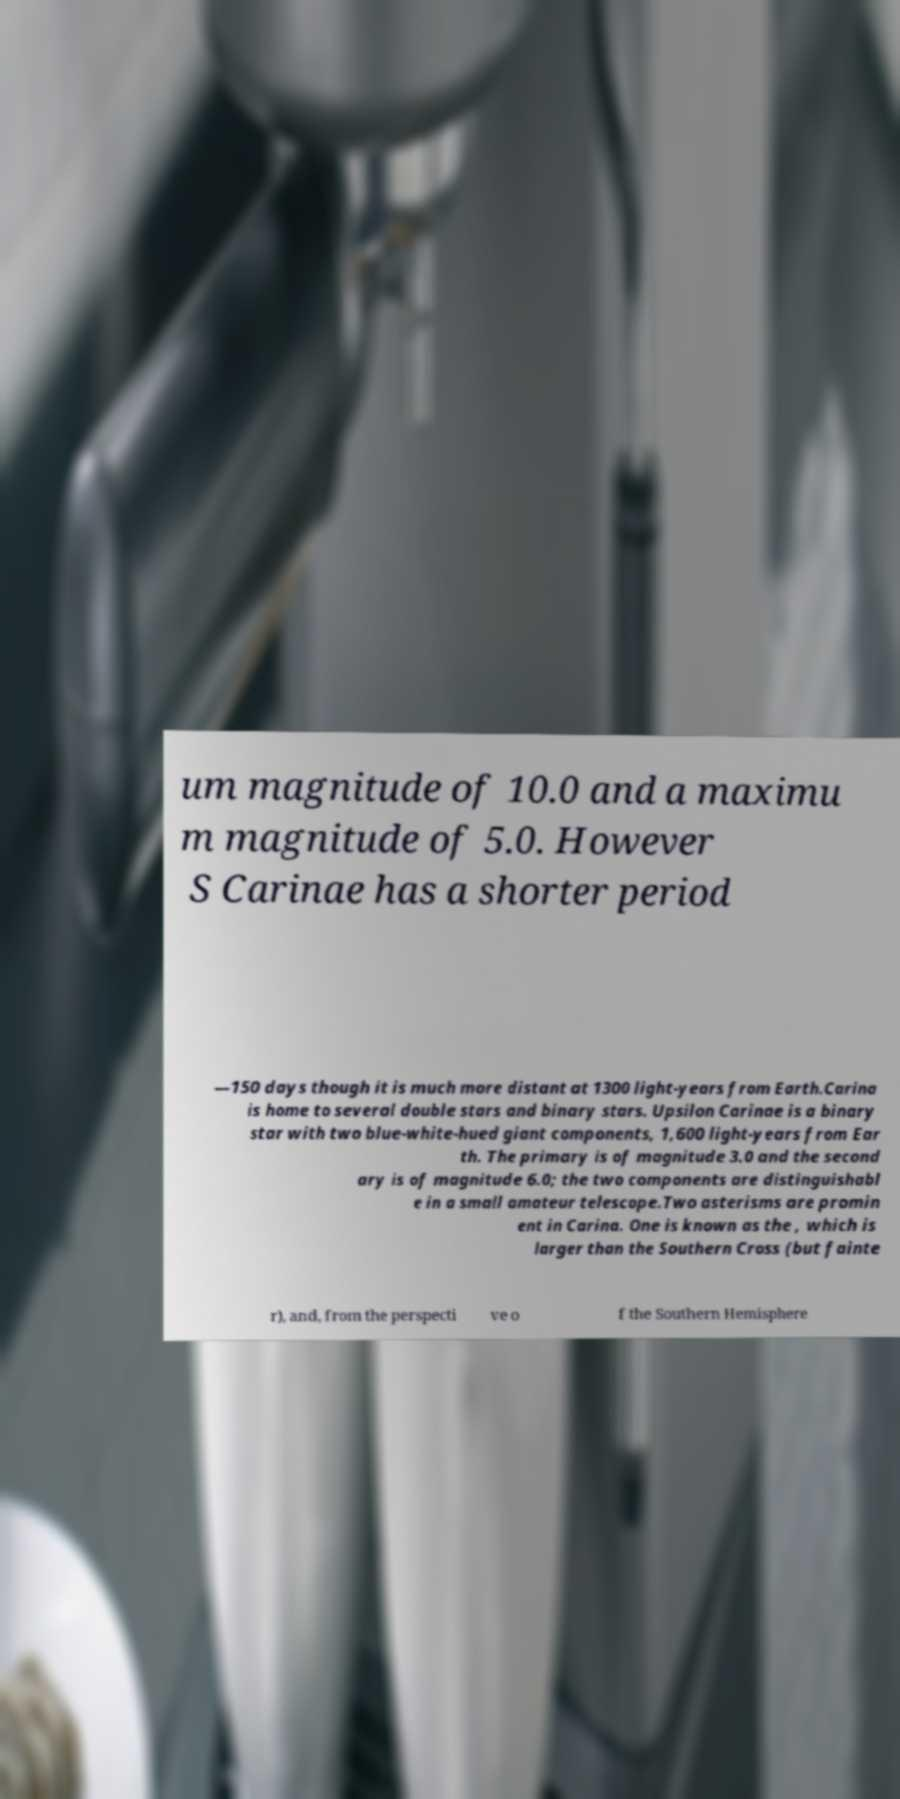Could you assist in decoding the text presented in this image and type it out clearly? um magnitude of 10.0 and a maximu m magnitude of 5.0. However S Carinae has a shorter period —150 days though it is much more distant at 1300 light-years from Earth.Carina is home to several double stars and binary stars. Upsilon Carinae is a binary star with two blue-white-hued giant components, 1,600 light-years from Ear th. The primary is of magnitude 3.0 and the second ary is of magnitude 6.0; the two components are distinguishabl e in a small amateur telescope.Two asterisms are promin ent in Carina. One is known as the , which is larger than the Southern Cross (but fainte r), and, from the perspecti ve o f the Southern Hemisphere 